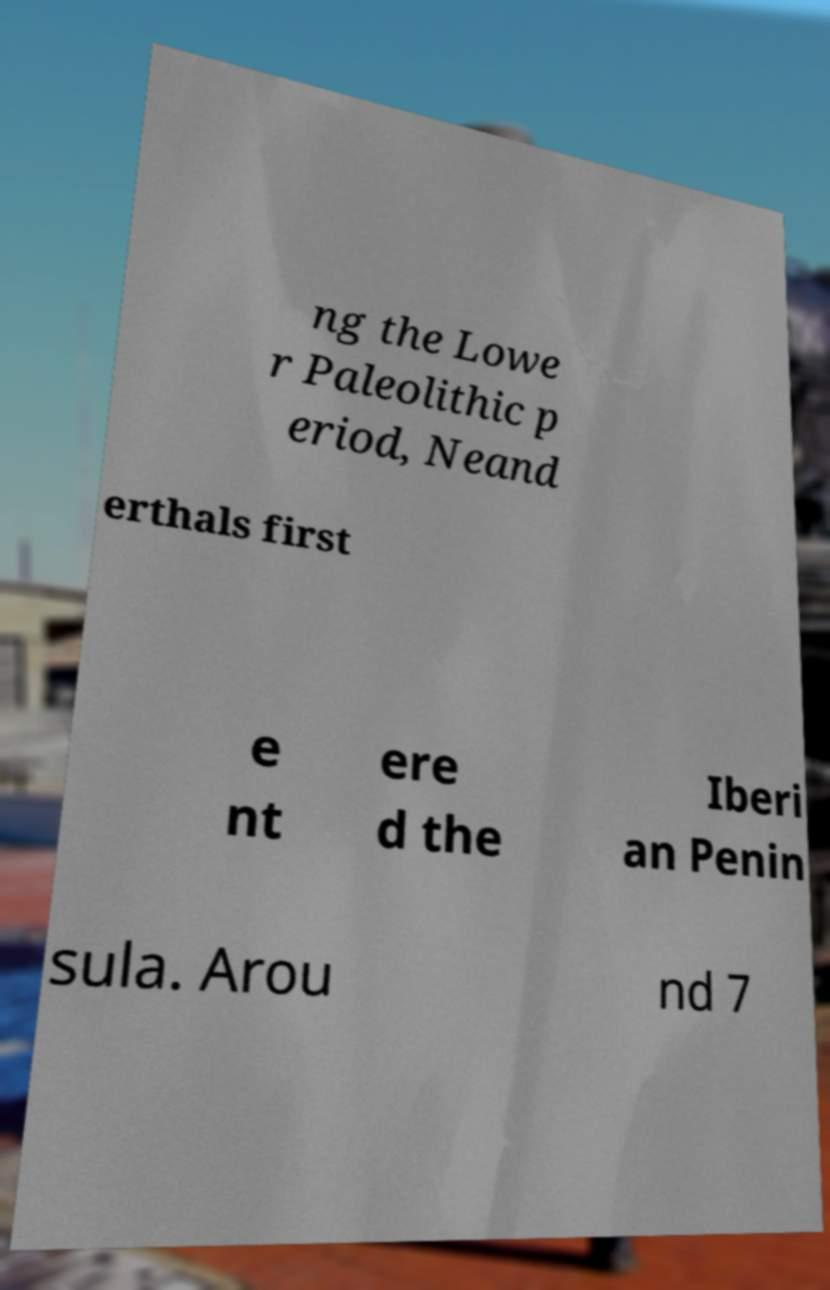What messages or text are displayed in this image? I need them in a readable, typed format. ng the Lowe r Paleolithic p eriod, Neand erthals first e nt ere d the Iberi an Penin sula. Arou nd 7 